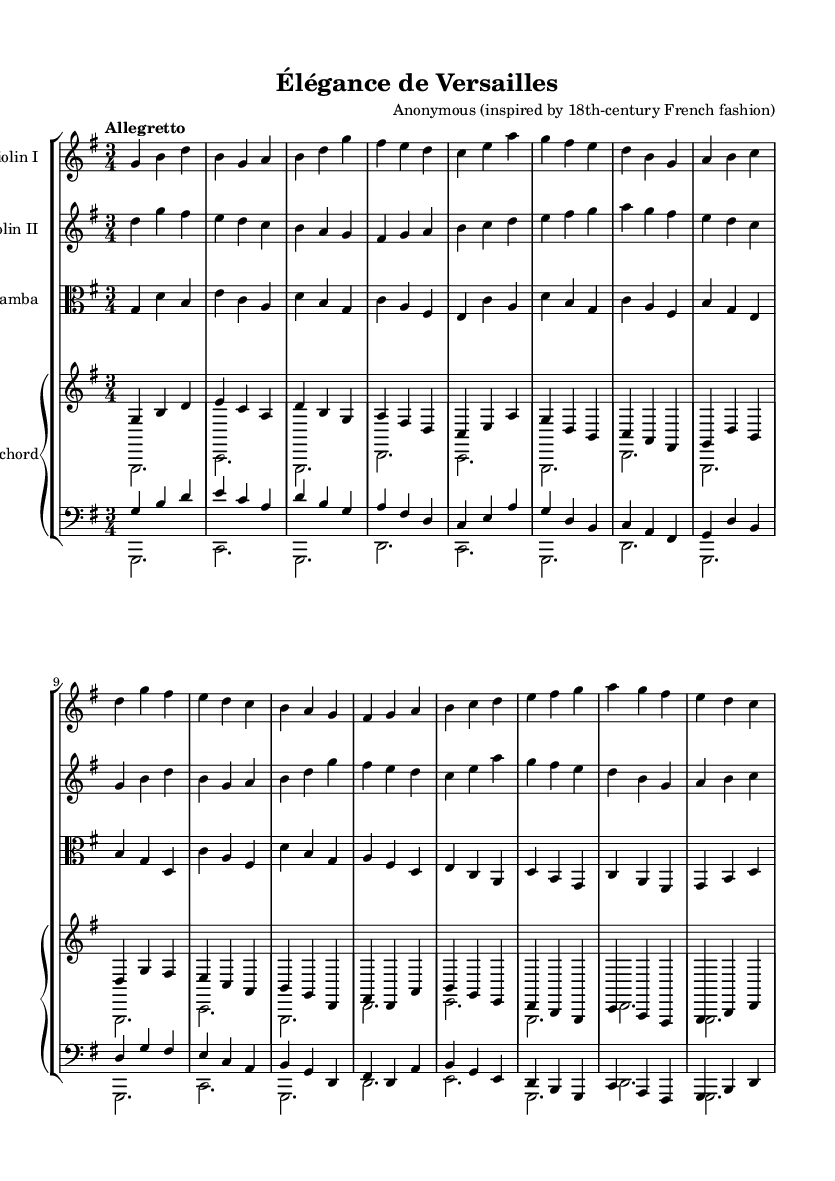What is the tempo marking of this music? The tempo marking at the beginning of the score indicates "Allegretto," suggesting a moderately fast pace.
Answer: Allegretto What is the time signature of this piece? The time signature shown at the beginning of the score is 3/4, indicating three beats per measure and a quarter note getting one beat.
Answer: 3/4 What instruments are featured in this chamber music? The score lists four instruments: Violin I, Violin II, Viola da gamba, and Harpsichord (with a separate staff for the bass).
Answer: Violin I, Violin II, Viola da gamba, Harpsichord Which key signature is used in this composition? The key signature indicated is G major, which has one sharp (F#), confirming the tonality that reflects the piece's structure.
Answer: G major How many measures does the Harpsichord part have in total? Counting the measures in the Harpsichord staff, there are a total of sixteen measures, including both treble and bass.
Answer: 16 What is the highest note played by the Violin I part? Review of the notes in the Violin I part shows that the highest note played is a b' (B in the second octave).
Answer: b Is this piece composed in a major or minor key overall? The G major key signature indicates that the piece is mainly composed in a major tonality, creating a bright and elegant atmosphere typical of Baroque music.
Answer: Major 